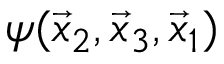<formula> <loc_0><loc_0><loc_500><loc_500>\psi ( \vec { x } _ { 2 } , \vec { x } _ { 3 } , \vec { x } _ { 1 } )</formula> 